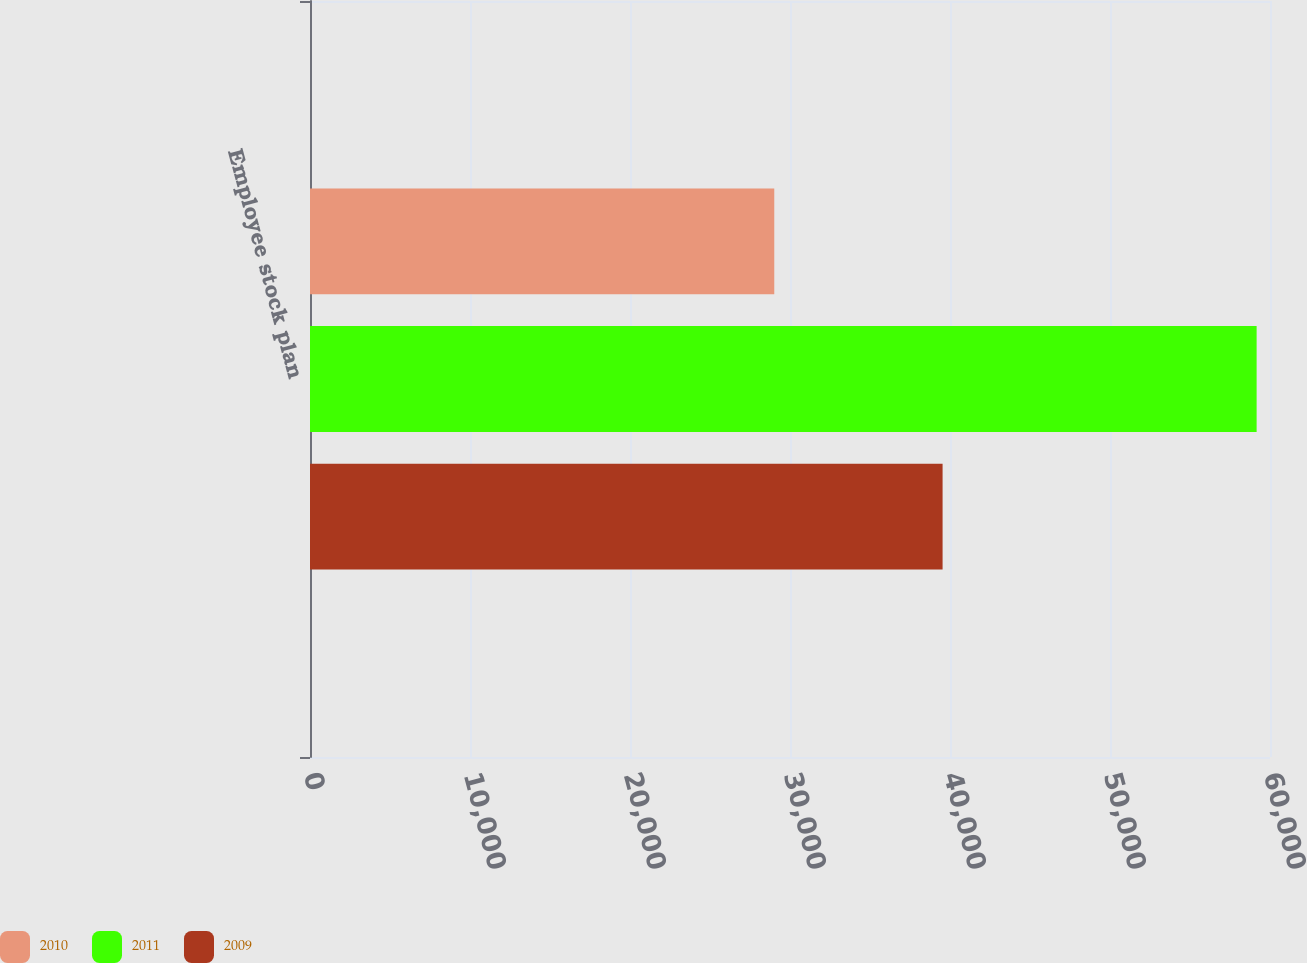Convert chart to OTSL. <chart><loc_0><loc_0><loc_500><loc_500><stacked_bar_chart><ecel><fcel>Employee stock plan<nl><fcel>2010<fcel>29017<nl><fcel>2011<fcel>59164<nl><fcel>2009<fcel>39537<nl></chart> 